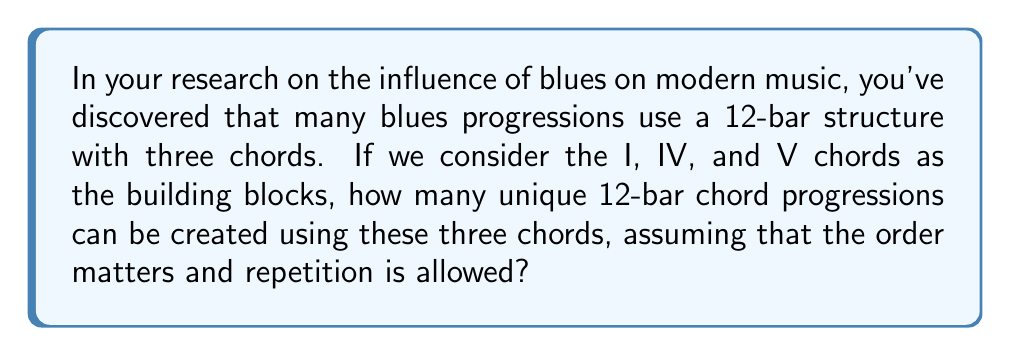Could you help me with this problem? To solve this problem, we need to use the concept of permutations with repetition from group theory. Here's how we can approach it:

1) We have 12 positions to fill in the chord progression.
2) For each position, we have 3 choices (I, IV, or V chord).
3) The order matters (e.g., I-IV-V is different from IV-V-I).
4) Repetition is allowed (we can use the same chord multiple times).

This scenario fits the formula for permutations with repetition:

$$ n^r $$

Where:
$n$ = number of options for each position (in this case, 3 chords)
$r$ = number of positions to fill (in this case, 12 bars)

Therefore, we can calculate the number of unique progressions as:

$$ 3^{12} $$

Let's compute this:

$$ 3^{12} = 3 \times 3 \times 3 \times 3 \times 3 \times 3 \times 3 \times 3 \times 3 \times 3 \times 3 \times 3 = 531,441 $$

This means there are 531,441 possible unique 12-bar chord progressions using the I, IV, and V chords.

It's worth noting that while this number represents all mathematical possibilities, in practice, blues musicians typically use a much smaller subset of these progressions, often following traditional patterns that have become characteristic of the blues genre.
Answer: 531,441 unique chord progressions 